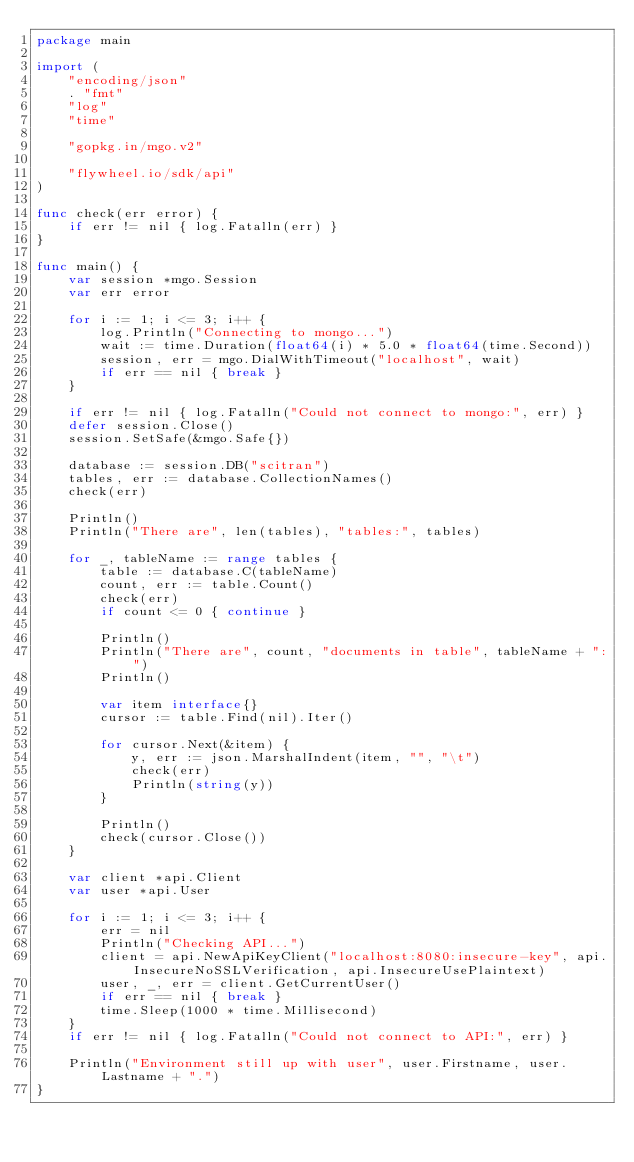<code> <loc_0><loc_0><loc_500><loc_500><_Go_>package main

import (
	"encoding/json"
	. "fmt"
	"log"
	"time"

	"gopkg.in/mgo.v2"

	"flywheel.io/sdk/api"
)

func check(err error) {
	if err != nil { log.Fatalln(err) }
}

func main() {
	var session *mgo.Session
	var err error

	for i := 1; i <= 3; i++ {
		log.Println("Connecting to mongo...")
		wait := time.Duration(float64(i) * 5.0 * float64(time.Second))
		session, err = mgo.DialWithTimeout("localhost", wait)
		if err == nil { break }
	}

	if err != nil { log.Fatalln("Could not connect to mongo:", err) }
	defer session.Close()
	session.SetSafe(&mgo.Safe{})

	database := session.DB("scitran")
	tables, err := database.CollectionNames()
	check(err)

	Println()
	Println("There are", len(tables), "tables:", tables)

	for _, tableName := range tables {
		table := database.C(tableName)
		count, err := table.Count()
		check(err)
		if count <= 0 { continue }

		Println()
		Println("There are", count, "documents in table", tableName + ":")
		Println()

		var item interface{}
		cursor := table.Find(nil).Iter()

		for cursor.Next(&item) {
			y, err := json.MarshalIndent(item, "", "\t")
			check(err)
			Println(string(y))
		}

		Println()
		check(cursor.Close())
	}

	var client *api.Client
	var user *api.User

	for i := 1; i <= 3; i++ {
		err = nil
		Println("Checking API...")
		client = api.NewApiKeyClient("localhost:8080:insecure-key", api.InsecureNoSSLVerification, api.InsecureUsePlaintext)
		user, _, err = client.GetCurrentUser()
		if err == nil { break }
		time.Sleep(1000 * time.Millisecond)
	}
	if err != nil {	log.Fatalln("Could not connect to API:", err) }

	Println("Environment still up with user", user.Firstname, user.Lastname + ".")
}
</code> 